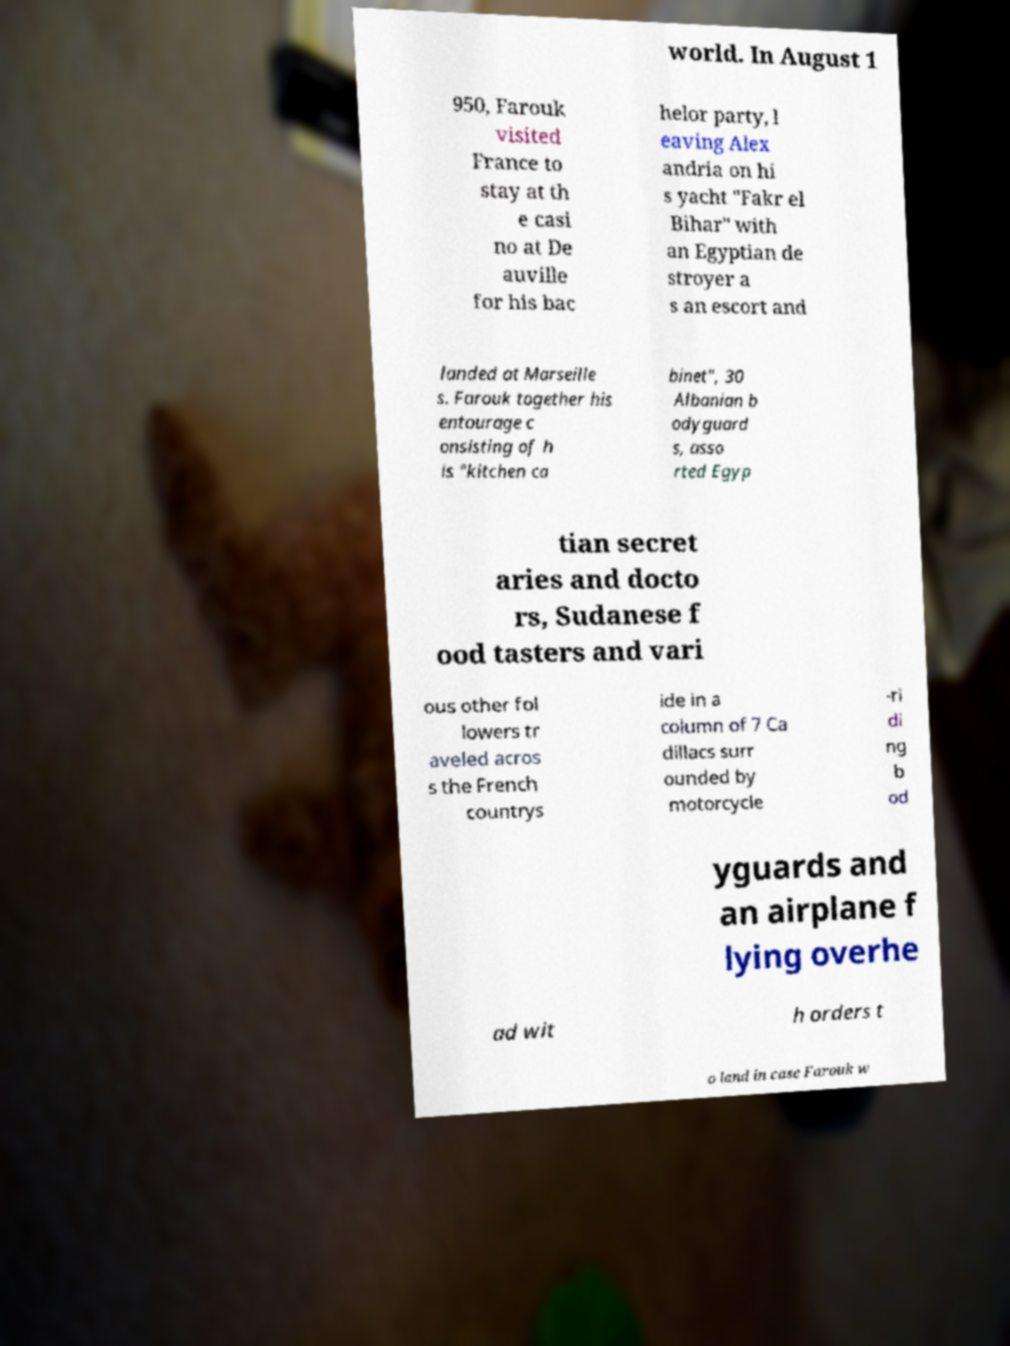Can you accurately transcribe the text from the provided image for me? world. In August 1 950, Farouk visited France to stay at th e casi no at De auville for his bac helor party, l eaving Alex andria on hi s yacht "Fakr el Bihar" with an Egyptian de stroyer a s an escort and landed at Marseille s. Farouk together his entourage c onsisting of h is "kitchen ca binet", 30 Albanian b odyguard s, asso rted Egyp tian secret aries and docto rs, Sudanese f ood tasters and vari ous other fol lowers tr aveled acros s the French countrys ide in a column of 7 Ca dillacs surr ounded by motorcycle -ri di ng b od yguards and an airplane f lying overhe ad wit h orders t o land in case Farouk w 